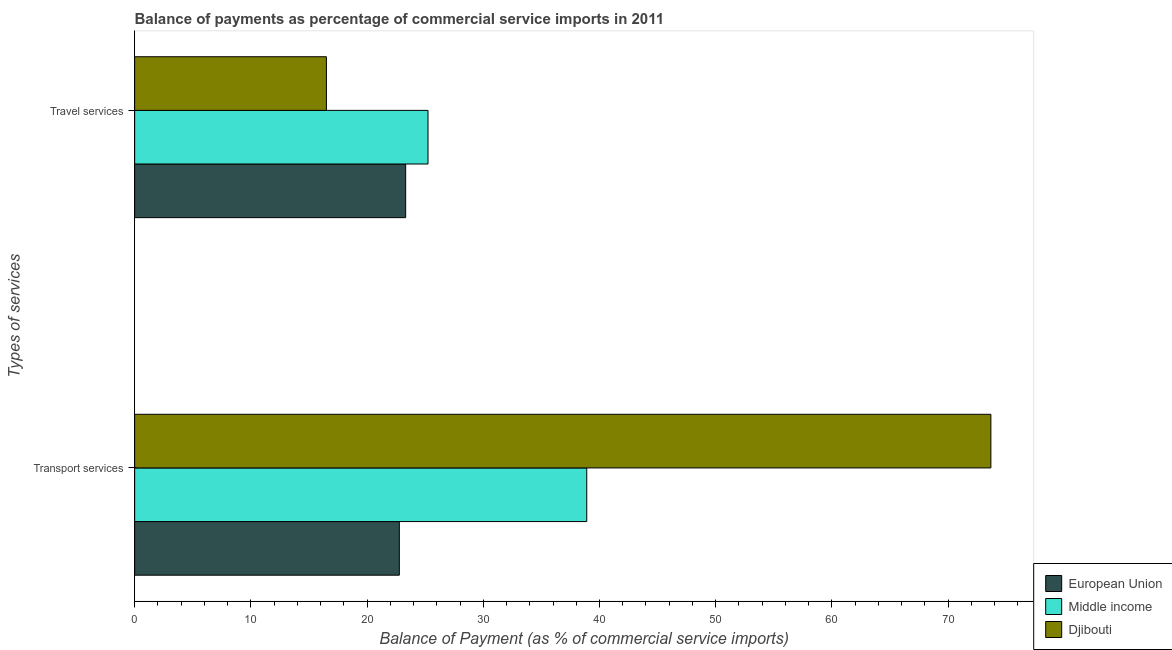Are the number of bars per tick equal to the number of legend labels?
Give a very brief answer. Yes. How many bars are there on the 1st tick from the top?
Give a very brief answer. 3. What is the label of the 2nd group of bars from the top?
Offer a very short reply. Transport services. What is the balance of payments of transport services in Djibouti?
Offer a very short reply. 73.68. Across all countries, what is the maximum balance of payments of travel services?
Offer a terse response. 25.24. Across all countries, what is the minimum balance of payments of transport services?
Provide a short and direct response. 22.78. In which country was the balance of payments of transport services maximum?
Your answer should be compact. Djibouti. In which country was the balance of payments of travel services minimum?
Give a very brief answer. Djibouti. What is the total balance of payments of transport services in the graph?
Your answer should be very brief. 135.36. What is the difference between the balance of payments of transport services in European Union and that in Middle income?
Give a very brief answer. -16.13. What is the difference between the balance of payments of travel services in European Union and the balance of payments of transport services in Djibouti?
Offer a terse response. -50.36. What is the average balance of payments of transport services per country?
Provide a succinct answer. 45.12. What is the difference between the balance of payments of travel services and balance of payments of transport services in European Union?
Your response must be concise. 0.55. What is the ratio of the balance of payments of transport services in Middle income to that in European Union?
Make the answer very short. 1.71. Is the balance of payments of travel services in Middle income less than that in Djibouti?
Offer a terse response. No. What does the 2nd bar from the top in Travel services represents?
Provide a short and direct response. Middle income. What does the 3rd bar from the bottom in Transport services represents?
Provide a short and direct response. Djibouti. Are all the bars in the graph horizontal?
Offer a very short reply. Yes. How many countries are there in the graph?
Keep it short and to the point. 3. What is the difference between two consecutive major ticks on the X-axis?
Your answer should be compact. 10. Are the values on the major ticks of X-axis written in scientific E-notation?
Offer a very short reply. No. Does the graph contain grids?
Offer a very short reply. No. What is the title of the graph?
Make the answer very short. Balance of payments as percentage of commercial service imports in 2011. What is the label or title of the X-axis?
Offer a terse response. Balance of Payment (as % of commercial service imports). What is the label or title of the Y-axis?
Keep it short and to the point. Types of services. What is the Balance of Payment (as % of commercial service imports) of European Union in Transport services?
Ensure brevity in your answer.  22.78. What is the Balance of Payment (as % of commercial service imports) of Middle income in Transport services?
Offer a very short reply. 38.9. What is the Balance of Payment (as % of commercial service imports) of Djibouti in Transport services?
Your answer should be compact. 73.68. What is the Balance of Payment (as % of commercial service imports) of European Union in Travel services?
Make the answer very short. 23.32. What is the Balance of Payment (as % of commercial service imports) of Middle income in Travel services?
Ensure brevity in your answer.  25.24. What is the Balance of Payment (as % of commercial service imports) of Djibouti in Travel services?
Offer a very short reply. 16.5. Across all Types of services, what is the maximum Balance of Payment (as % of commercial service imports) in European Union?
Your answer should be compact. 23.32. Across all Types of services, what is the maximum Balance of Payment (as % of commercial service imports) in Middle income?
Provide a succinct answer. 38.9. Across all Types of services, what is the maximum Balance of Payment (as % of commercial service imports) in Djibouti?
Ensure brevity in your answer.  73.68. Across all Types of services, what is the minimum Balance of Payment (as % of commercial service imports) of European Union?
Your answer should be compact. 22.78. Across all Types of services, what is the minimum Balance of Payment (as % of commercial service imports) of Middle income?
Your answer should be very brief. 25.24. Across all Types of services, what is the minimum Balance of Payment (as % of commercial service imports) in Djibouti?
Offer a terse response. 16.5. What is the total Balance of Payment (as % of commercial service imports) in European Union in the graph?
Keep it short and to the point. 46.1. What is the total Balance of Payment (as % of commercial service imports) of Middle income in the graph?
Provide a short and direct response. 64.15. What is the total Balance of Payment (as % of commercial service imports) of Djibouti in the graph?
Offer a very short reply. 90.18. What is the difference between the Balance of Payment (as % of commercial service imports) in European Union in Transport services and that in Travel services?
Ensure brevity in your answer.  -0.55. What is the difference between the Balance of Payment (as % of commercial service imports) in Middle income in Transport services and that in Travel services?
Provide a short and direct response. 13.66. What is the difference between the Balance of Payment (as % of commercial service imports) in Djibouti in Transport services and that in Travel services?
Make the answer very short. 57.18. What is the difference between the Balance of Payment (as % of commercial service imports) of European Union in Transport services and the Balance of Payment (as % of commercial service imports) of Middle income in Travel services?
Your answer should be very brief. -2.47. What is the difference between the Balance of Payment (as % of commercial service imports) of European Union in Transport services and the Balance of Payment (as % of commercial service imports) of Djibouti in Travel services?
Keep it short and to the point. 6.27. What is the difference between the Balance of Payment (as % of commercial service imports) in Middle income in Transport services and the Balance of Payment (as % of commercial service imports) in Djibouti in Travel services?
Make the answer very short. 22.4. What is the average Balance of Payment (as % of commercial service imports) in European Union per Types of services?
Provide a succinct answer. 23.05. What is the average Balance of Payment (as % of commercial service imports) of Middle income per Types of services?
Provide a short and direct response. 32.07. What is the average Balance of Payment (as % of commercial service imports) of Djibouti per Types of services?
Offer a very short reply. 45.09. What is the difference between the Balance of Payment (as % of commercial service imports) of European Union and Balance of Payment (as % of commercial service imports) of Middle income in Transport services?
Provide a short and direct response. -16.13. What is the difference between the Balance of Payment (as % of commercial service imports) in European Union and Balance of Payment (as % of commercial service imports) in Djibouti in Transport services?
Your response must be concise. -50.9. What is the difference between the Balance of Payment (as % of commercial service imports) in Middle income and Balance of Payment (as % of commercial service imports) in Djibouti in Transport services?
Keep it short and to the point. -34.77. What is the difference between the Balance of Payment (as % of commercial service imports) in European Union and Balance of Payment (as % of commercial service imports) in Middle income in Travel services?
Offer a very short reply. -1.92. What is the difference between the Balance of Payment (as % of commercial service imports) in European Union and Balance of Payment (as % of commercial service imports) in Djibouti in Travel services?
Make the answer very short. 6.82. What is the difference between the Balance of Payment (as % of commercial service imports) of Middle income and Balance of Payment (as % of commercial service imports) of Djibouti in Travel services?
Give a very brief answer. 8.74. What is the ratio of the Balance of Payment (as % of commercial service imports) of European Union in Transport services to that in Travel services?
Provide a succinct answer. 0.98. What is the ratio of the Balance of Payment (as % of commercial service imports) of Middle income in Transport services to that in Travel services?
Provide a succinct answer. 1.54. What is the ratio of the Balance of Payment (as % of commercial service imports) of Djibouti in Transport services to that in Travel services?
Provide a short and direct response. 4.46. What is the difference between the highest and the second highest Balance of Payment (as % of commercial service imports) in European Union?
Provide a short and direct response. 0.55. What is the difference between the highest and the second highest Balance of Payment (as % of commercial service imports) of Middle income?
Give a very brief answer. 13.66. What is the difference between the highest and the second highest Balance of Payment (as % of commercial service imports) of Djibouti?
Offer a very short reply. 57.18. What is the difference between the highest and the lowest Balance of Payment (as % of commercial service imports) in European Union?
Offer a very short reply. 0.55. What is the difference between the highest and the lowest Balance of Payment (as % of commercial service imports) of Middle income?
Offer a terse response. 13.66. What is the difference between the highest and the lowest Balance of Payment (as % of commercial service imports) of Djibouti?
Your response must be concise. 57.18. 